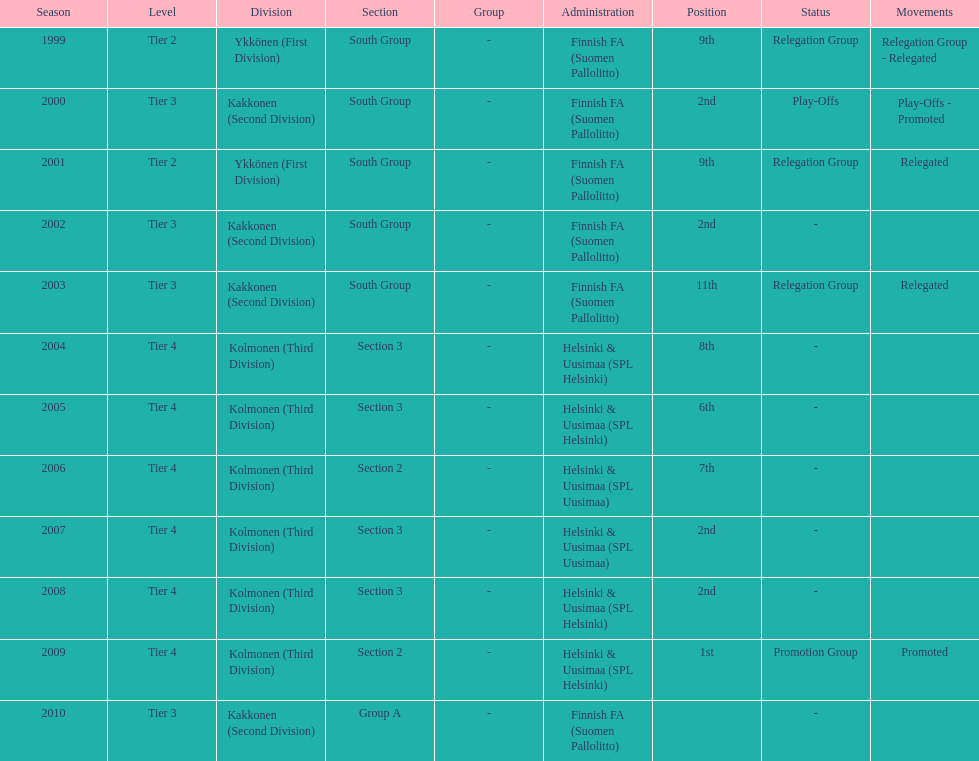Which administration has the least amount of division? Helsinki & Uusimaa (SPL Helsinki). 